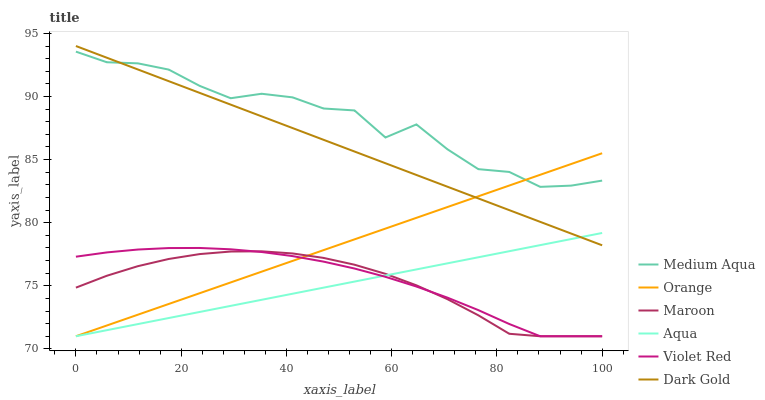Does Dark Gold have the minimum area under the curve?
Answer yes or no. No. Does Dark Gold have the maximum area under the curve?
Answer yes or no. No. Is Dark Gold the smoothest?
Answer yes or no. No. Is Dark Gold the roughest?
Answer yes or no. No. Does Dark Gold have the lowest value?
Answer yes or no. No. Does Aqua have the highest value?
Answer yes or no. No. Is Maroon less than Dark Gold?
Answer yes or no. Yes. Is Medium Aqua greater than Violet Red?
Answer yes or no. Yes. Does Maroon intersect Dark Gold?
Answer yes or no. No. 